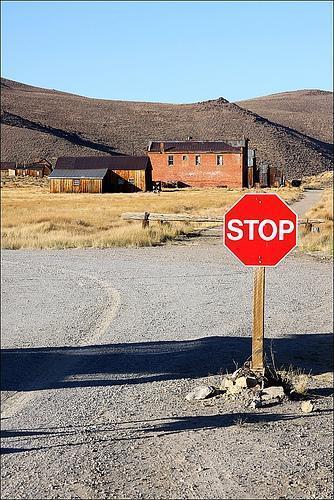How many signs are there?
Give a very brief answer. 1. How many people are in the picture?
Give a very brief answer. 0. 